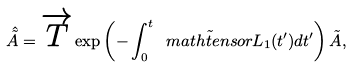Convert formula to latex. <formula><loc_0><loc_0><loc_500><loc_500>\hat { \tilde { A } } = \overrightarrow { T } \exp \left ( - \int _ { 0 } ^ { t } \tilde { \ m a t h t e n s o r { L } } _ { 1 } ( t ^ { \prime } ) d t ^ { \prime } \right ) \tilde { A } ,</formula> 